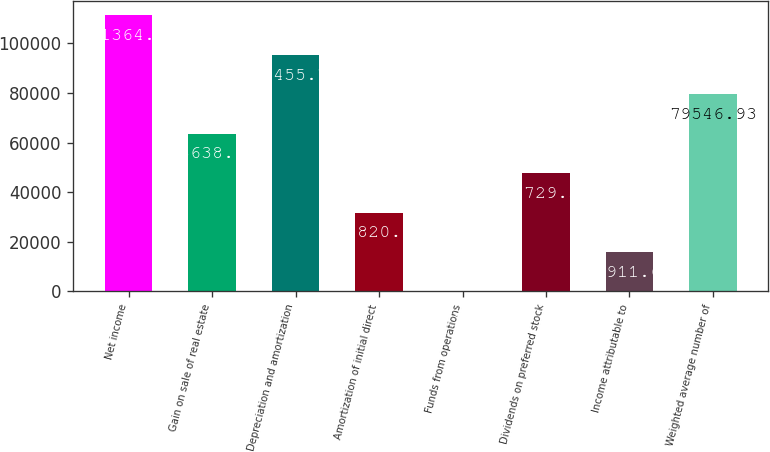Convert chart to OTSL. <chart><loc_0><loc_0><loc_500><loc_500><bar_chart><fcel>Net income<fcel>Gain on sale of real estate<fcel>Depreciation and amortization<fcel>Amortization of initial direct<fcel>Funds from operations<fcel>Dividends on preferred stock<fcel>Income attributable to<fcel>Weighted average number of<nl><fcel>111365<fcel>63638.1<fcel>95455.7<fcel>31820.5<fcel>2.85<fcel>47729.3<fcel>15911.7<fcel>79546.9<nl></chart> 